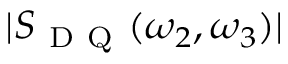<formula> <loc_0><loc_0><loc_500><loc_500>| S _ { D Q } ( \omega _ { 2 } , \omega _ { 3 } ) |</formula> 